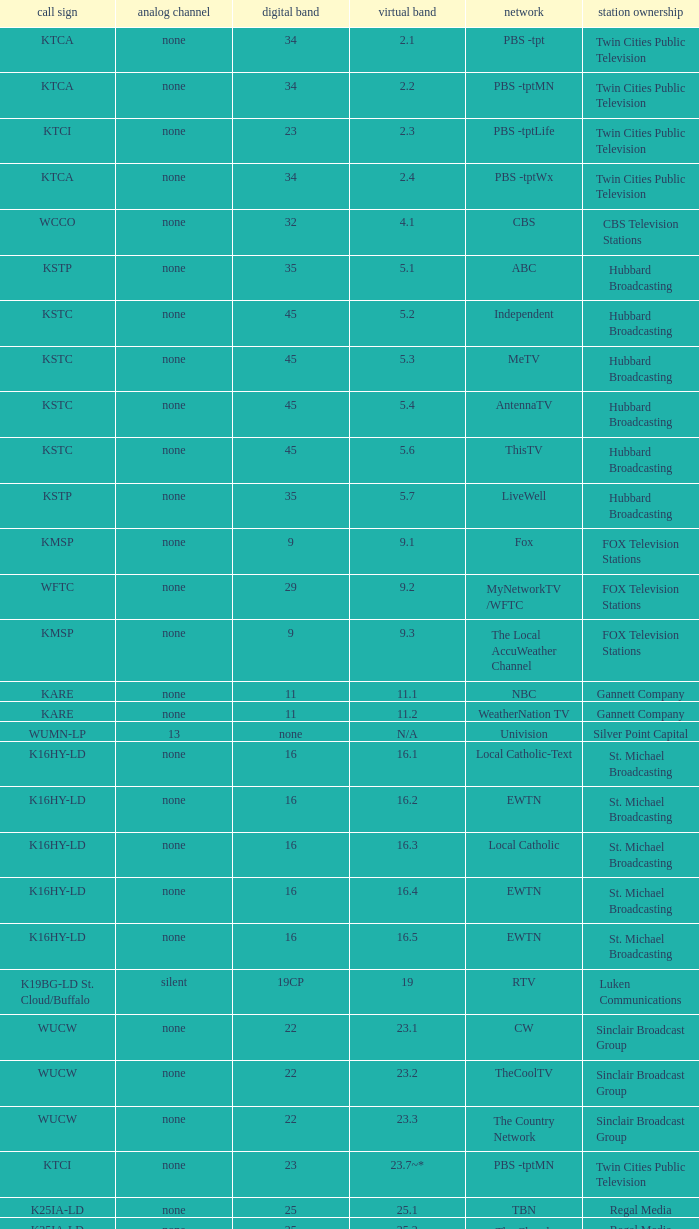For digital channel 32, what is the associated analog channel? None. 